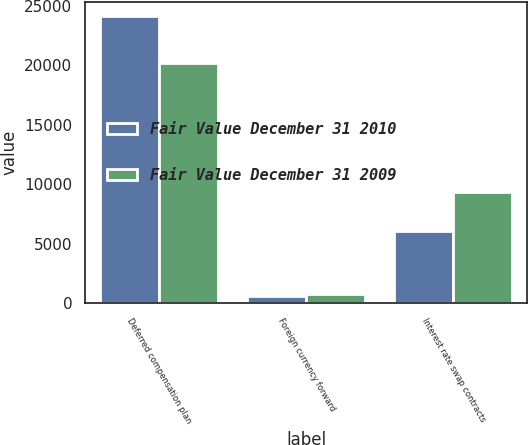Convert chart. <chart><loc_0><loc_0><loc_500><loc_500><stacked_bar_chart><ecel><fcel>Deferred compensation plan<fcel>Foreign currency forward<fcel>Interest rate swap contracts<nl><fcel>Fair Value December 31 2010<fcel>24113<fcel>618<fcel>6067<nl><fcel>Fair Value December 31 2009<fcel>20214<fcel>740<fcel>9363<nl></chart> 